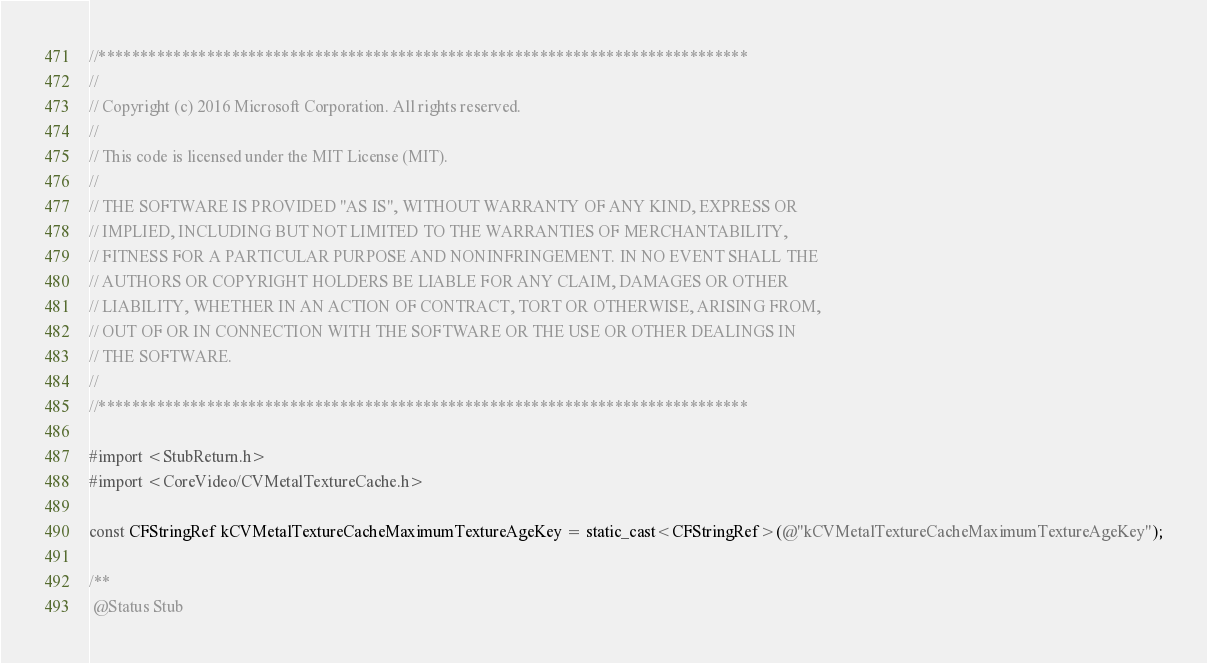<code> <loc_0><loc_0><loc_500><loc_500><_ObjectiveC_>//******************************************************************************
//
// Copyright (c) 2016 Microsoft Corporation. All rights reserved.
//
// This code is licensed under the MIT License (MIT).
//
// THE SOFTWARE IS PROVIDED "AS IS", WITHOUT WARRANTY OF ANY KIND, EXPRESS OR
// IMPLIED, INCLUDING BUT NOT LIMITED TO THE WARRANTIES OF MERCHANTABILITY,
// FITNESS FOR A PARTICULAR PURPOSE AND NONINFRINGEMENT. IN NO EVENT SHALL THE
// AUTHORS OR COPYRIGHT HOLDERS BE LIABLE FOR ANY CLAIM, DAMAGES OR OTHER
// LIABILITY, WHETHER IN AN ACTION OF CONTRACT, TORT OR OTHERWISE, ARISING FROM,
// OUT OF OR IN CONNECTION WITH THE SOFTWARE OR THE USE OR OTHER DEALINGS IN
// THE SOFTWARE.
//
//******************************************************************************

#import <StubReturn.h>
#import <CoreVideo/CVMetalTextureCache.h>

const CFStringRef kCVMetalTextureCacheMaximumTextureAgeKey = static_cast<CFStringRef>(@"kCVMetalTextureCacheMaximumTextureAgeKey");

/**
 @Status Stub</code> 